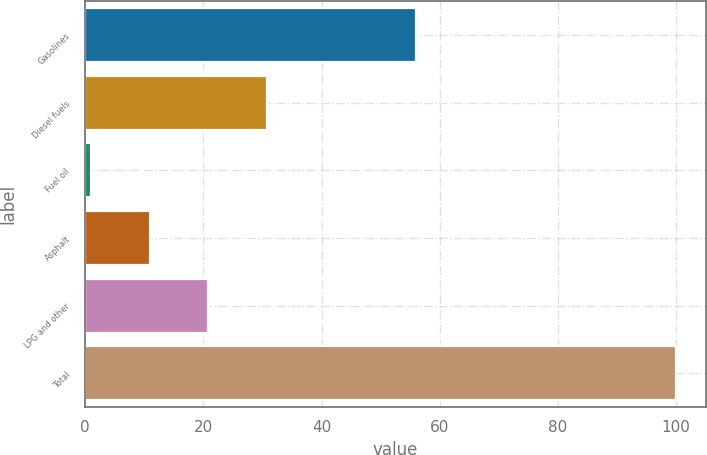Convert chart to OTSL. <chart><loc_0><loc_0><loc_500><loc_500><bar_chart><fcel>Gasolines<fcel>Diesel fuels<fcel>Fuel oil<fcel>Asphalt<fcel>LPG and other<fcel>Total<nl><fcel>56<fcel>30.7<fcel>1<fcel>10.9<fcel>20.8<fcel>100<nl></chart> 